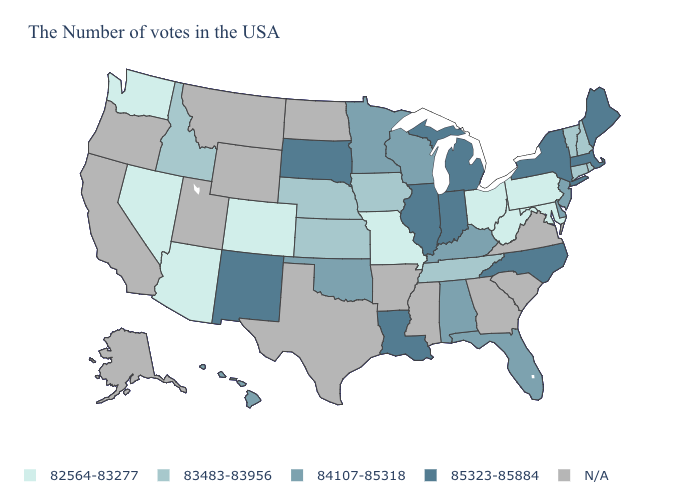Does Florida have the highest value in the South?
Keep it brief. No. What is the lowest value in the West?
Write a very short answer. 82564-83277. What is the value of Maryland?
Short answer required. 82564-83277. What is the value of Hawaii?
Answer briefly. 84107-85318. What is the value of South Dakota?
Write a very short answer. 85323-85884. Name the states that have a value in the range 85323-85884?
Quick response, please. Maine, Massachusetts, New York, North Carolina, Michigan, Indiana, Illinois, Louisiana, South Dakota, New Mexico. What is the value of Maryland?
Keep it brief. 82564-83277. Does North Carolina have the highest value in the USA?
Be succinct. Yes. What is the value of Arizona?
Answer briefly. 82564-83277. What is the value of North Dakota?
Short answer required. N/A. Name the states that have a value in the range N/A?
Be succinct. Virginia, South Carolina, Georgia, Mississippi, Arkansas, Texas, North Dakota, Wyoming, Utah, Montana, California, Oregon, Alaska. Among the states that border South Dakota , does Nebraska have the lowest value?
Short answer required. Yes. Does Indiana have the lowest value in the USA?
Short answer required. No. Which states have the highest value in the USA?
Quick response, please. Maine, Massachusetts, New York, North Carolina, Michigan, Indiana, Illinois, Louisiana, South Dakota, New Mexico. 